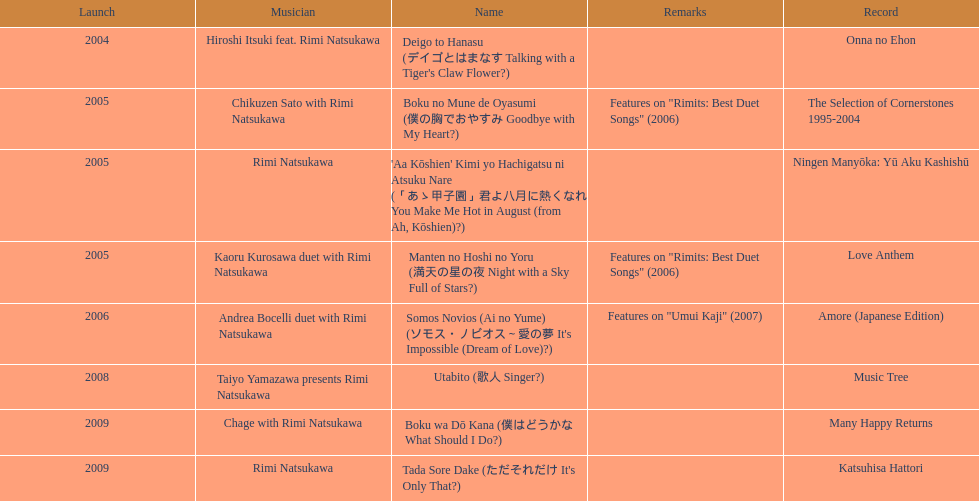How many other appearance did this artist make in 2005? 3. 